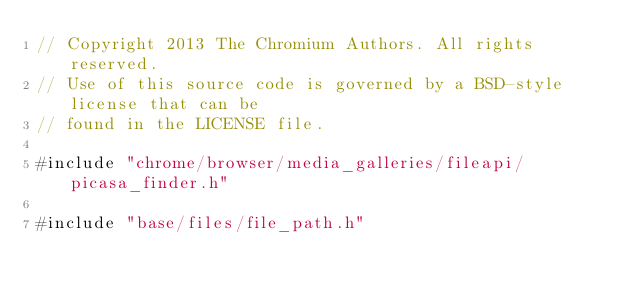Convert code to text. <code><loc_0><loc_0><loc_500><loc_500><_ObjectiveC_>// Copyright 2013 The Chromium Authors. All rights reserved.
// Use of this source code is governed by a BSD-style license that can be
// found in the LICENSE file.

#include "chrome/browser/media_galleries/fileapi/picasa_finder.h"

#include "base/files/file_path.h"</code> 